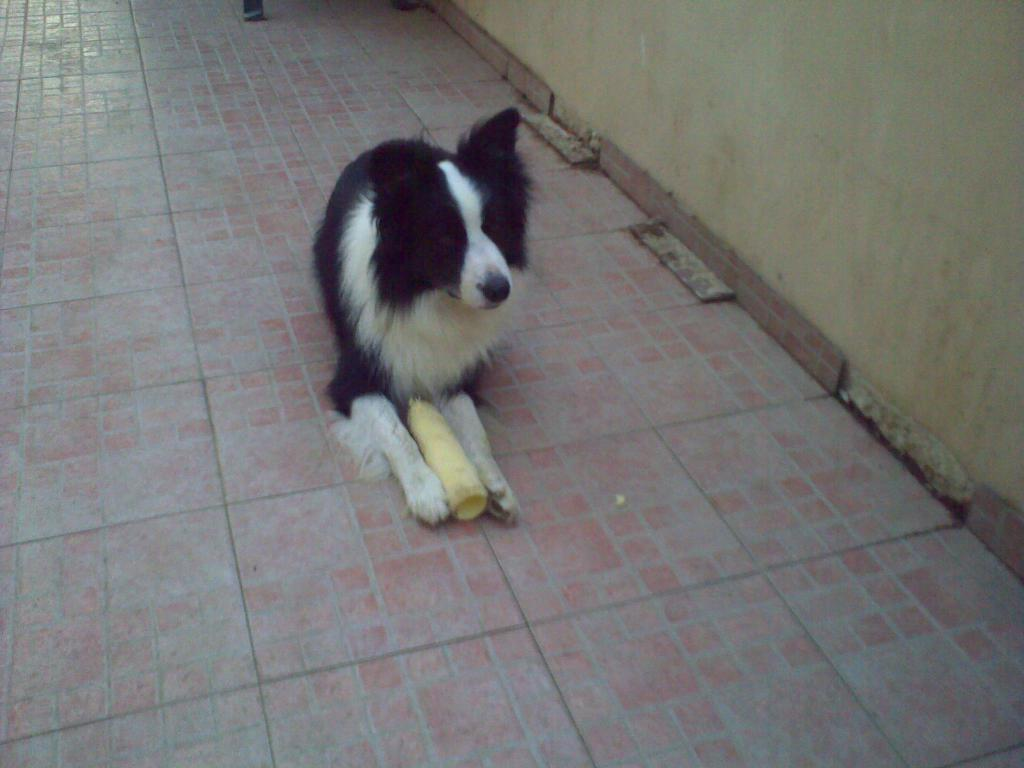What type of animal is present in the image? There is a dog in the image. What can be found on the ground in the image? There is an object on the ground in the image. What is visible in the background of the image? There is a wall visible in the image. What is located at the top of the image? There is an object at the top of the image. Can you see any squirrels climbing the fruit tree in the image? There is no fruit tree or squirrel present in the image. 